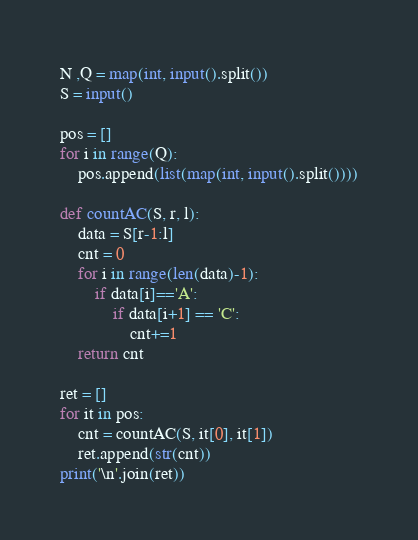Convert code to text. <code><loc_0><loc_0><loc_500><loc_500><_Python_>N ,Q = map(int, input().split())
S = input()

pos = []
for i in range(Q):
    pos.append(list(map(int, input().split())))
    
def countAC(S, r, l):
    data = S[r-1:l]
    cnt = 0
    for i in range(len(data)-1):
        if data[i]=='A':
            if data[i+1] == 'C':
                cnt+=1
    return cnt
  
ret = []
for it in pos:
    cnt = countAC(S, it[0], it[1])
    ret.append(str(cnt))
print('\n'.join(ret))</code> 